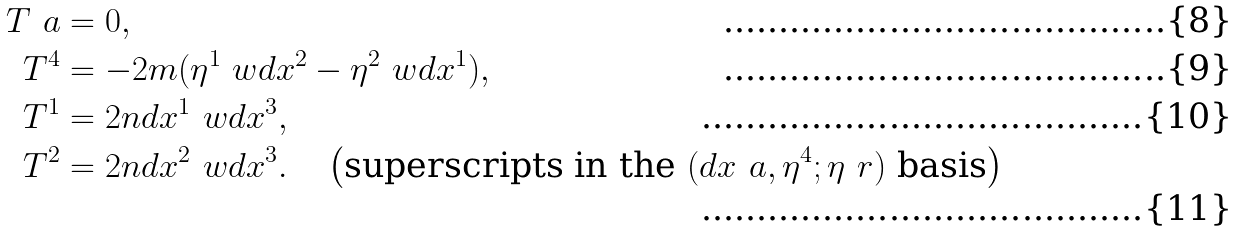Convert formula to latex. <formula><loc_0><loc_0><loc_500><loc_500>T ^ { \ } a & = 0 , \\ T ^ { 4 } & = - 2 m ( \eta ^ { 1 } \ w d x ^ { 2 } - \eta ^ { 2 } \ w d x ^ { 1 } ) , \\ T ^ { 1 } & = 2 n d x ^ { 1 } \ w d x ^ { 3 } , \\ T ^ { 2 } & = 2 n d x ^ { 2 } \ w d x ^ { 3 } . \quad \left ( \text {superscripts in the } ( d x ^ { \ } a , \eta ^ { 4 } ; \eta ^ { \ } r ) \text { basis} \right )</formula> 